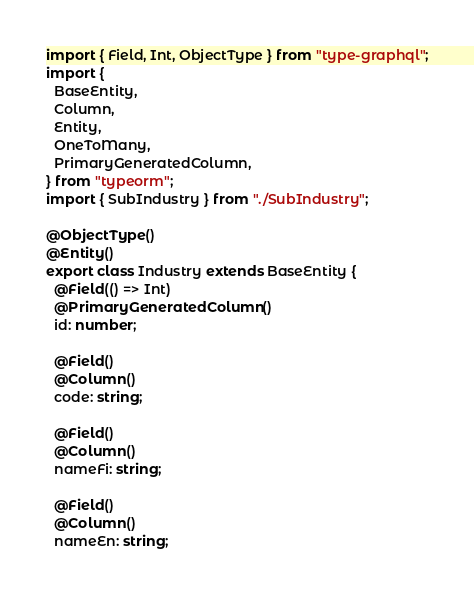Convert code to text. <code><loc_0><loc_0><loc_500><loc_500><_TypeScript_>import { Field, Int, ObjectType } from "type-graphql";
import {
  BaseEntity,
  Column,
  Entity,
  OneToMany,
  PrimaryGeneratedColumn,
} from "typeorm";
import { SubIndustry } from "./SubIndustry";

@ObjectType()
@Entity()
export class Industry extends BaseEntity {
  @Field(() => Int)
  @PrimaryGeneratedColumn()
  id: number;

  @Field()
  @Column()
  code: string;

  @Field()
  @Column()
  nameFi: string;

  @Field()
  @Column()
  nameEn: string;
</code> 